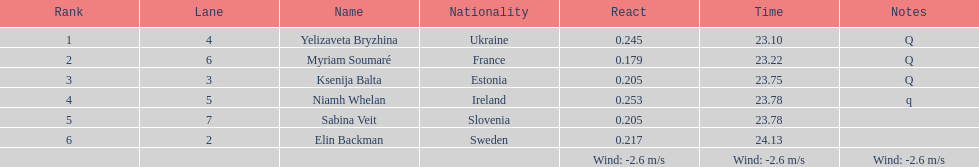How many surnames begin with "b"? 3. 